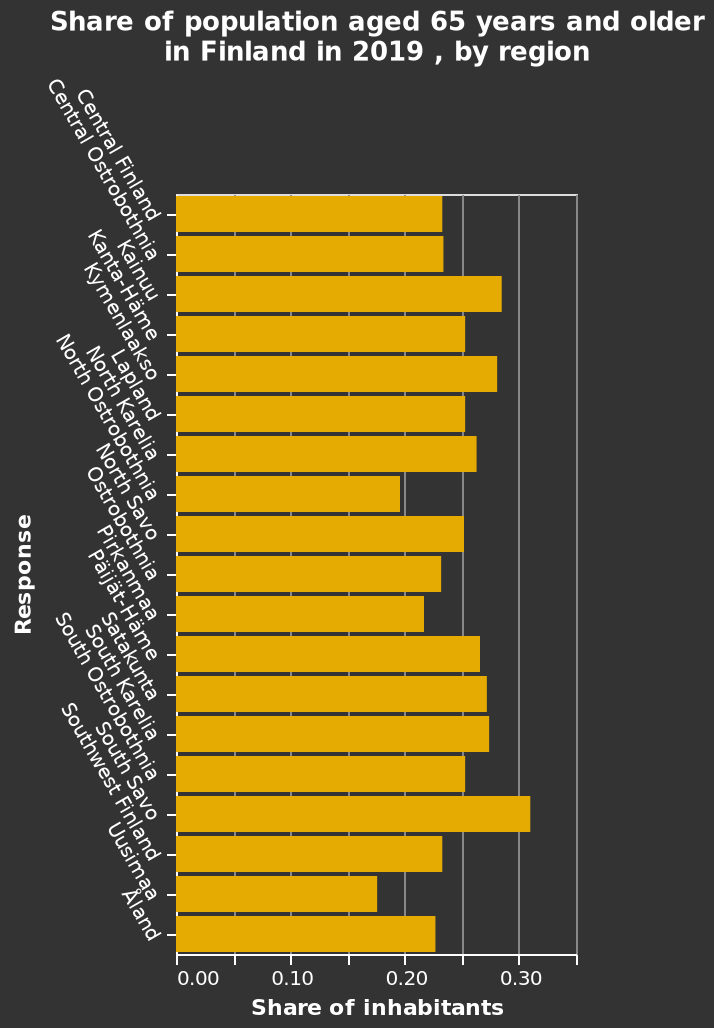<image>
What region had the highest percentage of people over the age of 65 in 2019? The region with the highest percentage of people over the age of 65 in 2019 was South Stave. Offer a thorough analysis of the image. The highest populated area for those 65 and over is south savo. What was the difference in percentage between South Stave and Kianuu and Kymenlaakso? The difference in percentage between South Stave and Kianuu and Kymenlaakso was about 0.32. please describe the details of the chart This bar chart is called Share of population aged 65 years and older in Finland in 2019 , by region. The x-axis measures Share of inhabitants with scale of range 0.00 to 0.35 while the y-axis measures Response as categorical scale starting with Central Finland and ending with Åland. 